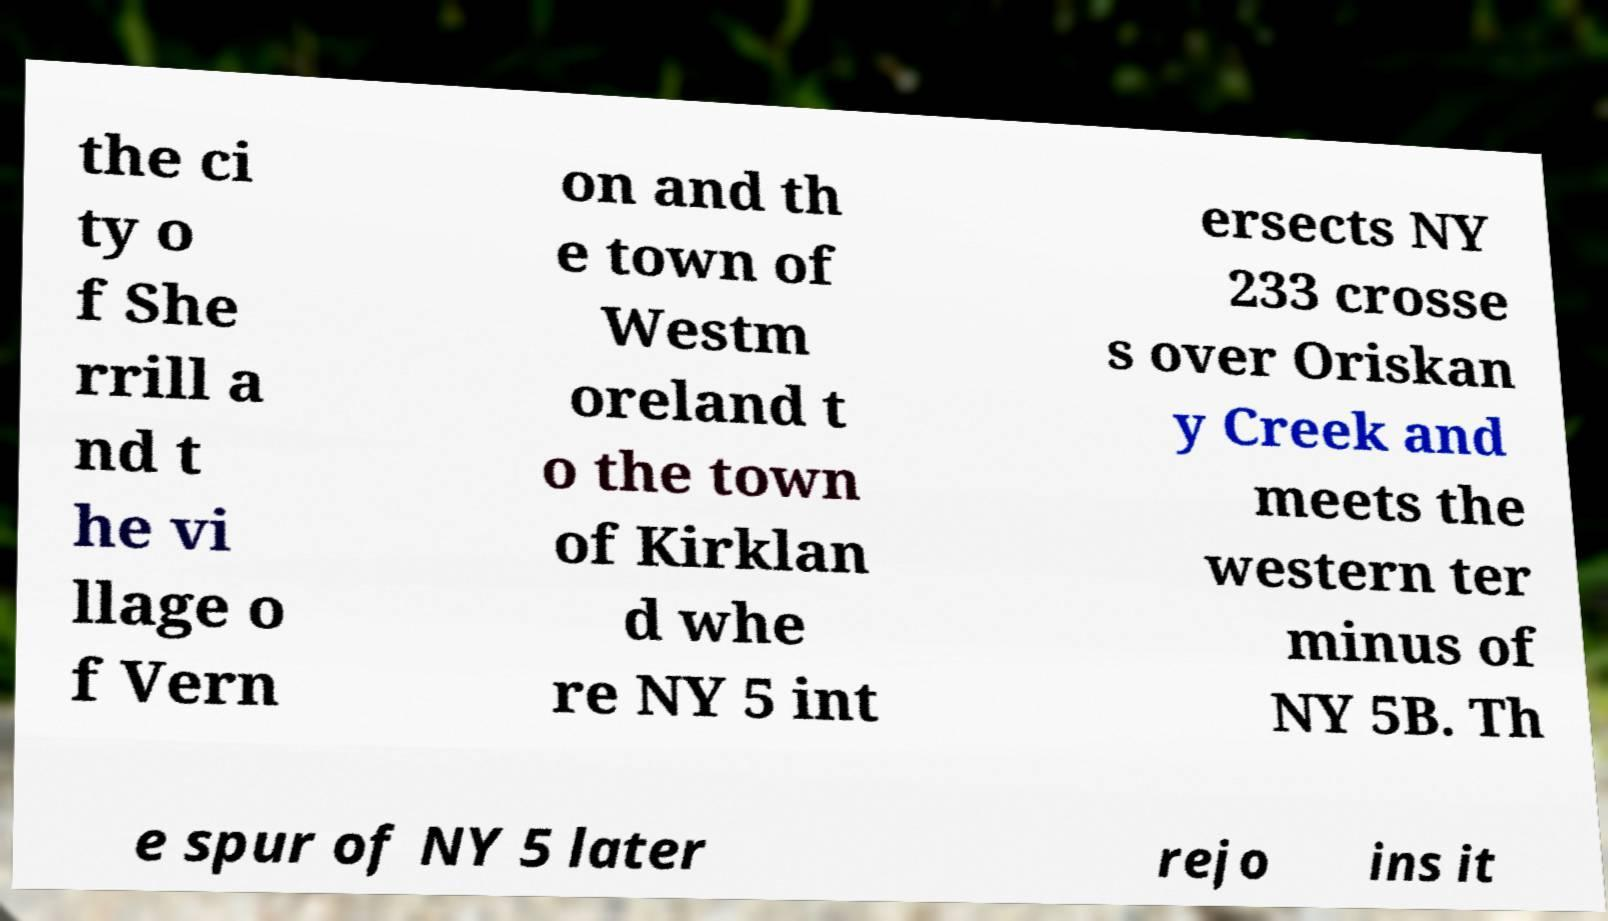There's text embedded in this image that I need extracted. Can you transcribe it verbatim? the ci ty o f She rrill a nd t he vi llage o f Vern on and th e town of Westm oreland t o the town of Kirklan d whe re NY 5 int ersects NY 233 crosse s over Oriskan y Creek and meets the western ter minus of NY 5B. Th e spur of NY 5 later rejo ins it 